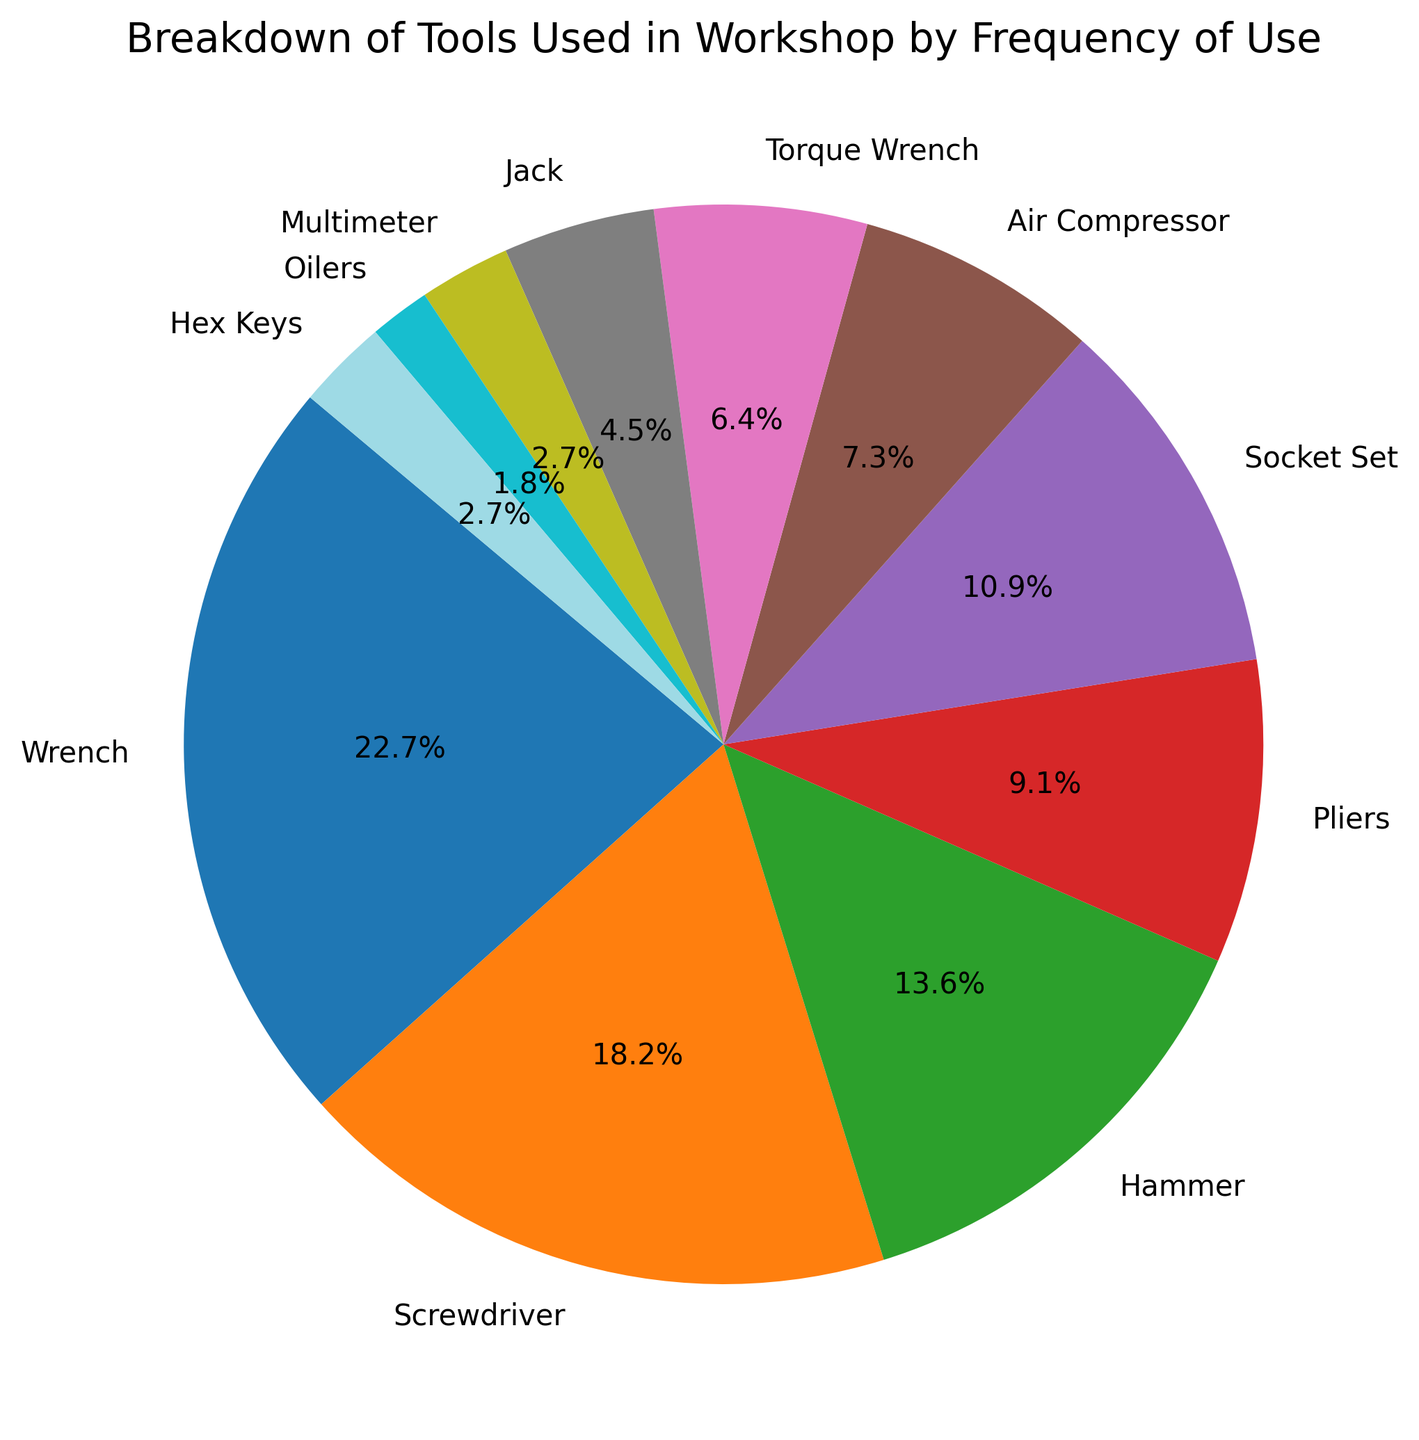What's the most frequently used tool? The largest segment in the pie chart corresponds to the wrench, indicating it has the highest frequency of use.
Answer: Wrench Which tools together make up more than 50% of the chart? The tools with the largest segments in descending order are wrench (25%), screwdriver (20%), and hammer (15%). Adding these percentages gives 25% + 20% + 15% = 60%, which is more than half of the chart.
Answer: Wrench, Screwdriver, Hammer Which tool has the smallest percentage of use, and what is that percentage? The smallest slice in the pie chart is for oilers, which shows 2% usage frequency.
Answer: Oilers, 2% How does the usage frequency of the air compressor compare to that of the torque wrench? The chart shows that the air compressor is used more frequently than the torque wrench: 8% versus 7%.
Answer: Air Compressor > Torque Wrench What is the combined frequency percentage of the multimeter and hex keys? The pie chart shows multimeter usage at 3% and hex keys also at 3%. Adding them together, we get 3% + 3% = 6%.
Answer: 6% Which tools have an equal frequency of use? The pie chart shows both the multimeter and hex keys have the same frequency of use, each at 3%.
Answer: Multimeter, Hex Keys How many tools have a usage frequency below 10%? By inspecting the pie chart, we find that pliers (10%), socket set (12%), air compressor (8%), torque wrench (7%), jack (5%), multimeter (3%), oilers (2%), and hex keys (3%) all have segments below 10%, making a total of 6 tools.
Answer: 6 What is the difference in frequency usage between the most and least used tools? The pie chart shows the wrench is used 25% of the time, and the oilers are used 2% of the time. The difference is 25% - 2% = 23%.
Answer: 23% What's the total frequency percentage of wrench, screwdriver, and hammer compared to the rest of the tools? The pie chart indicates the wrench (25%), screwdriver (20%), and hammer (15%) together make up 25% + 20% + 15% = 60%. The rest of the tools make up 100% - 60% = 40%.
Answer: 60% vs 40% How much more frequently are screwdrivers used compared to jacks? Screwdrivers make up 20% and jacks 5% of the pie chart. The difference in their frequencies is 20% - 5% = 15%.
Answer: 15% 